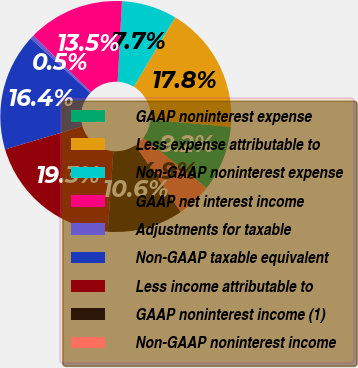Convert chart. <chart><loc_0><loc_0><loc_500><loc_500><pie_chart><fcel>GAAP noninterest expense<fcel>Less expense attributable to<fcel>Non-GAAP noninterest expense<fcel>GAAP net interest income<fcel>Adjustments for taxable<fcel>Non-GAAP taxable equivalent<fcel>Less income attributable to<fcel>GAAP noninterest income (1)<fcel>Non-GAAP noninterest income<nl><fcel>9.19%<fcel>17.85%<fcel>7.74%<fcel>13.52%<fcel>0.53%<fcel>16.4%<fcel>19.29%<fcel>10.63%<fcel>4.86%<nl></chart> 